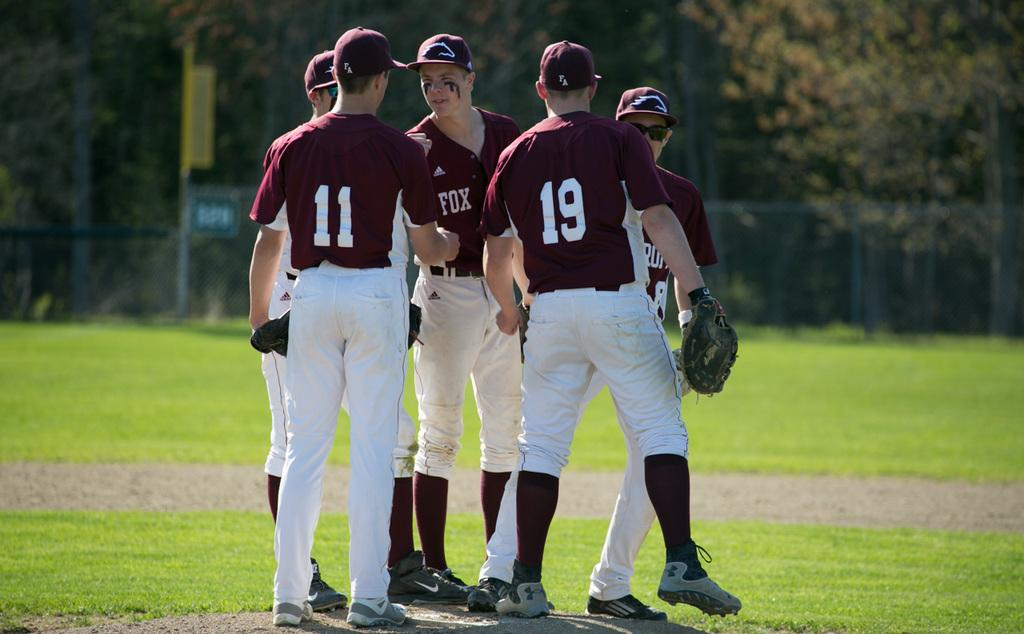<image>
Give a short and clear explanation of the subsequent image. Players huddle up including those wearing numbers 11 and 19. 